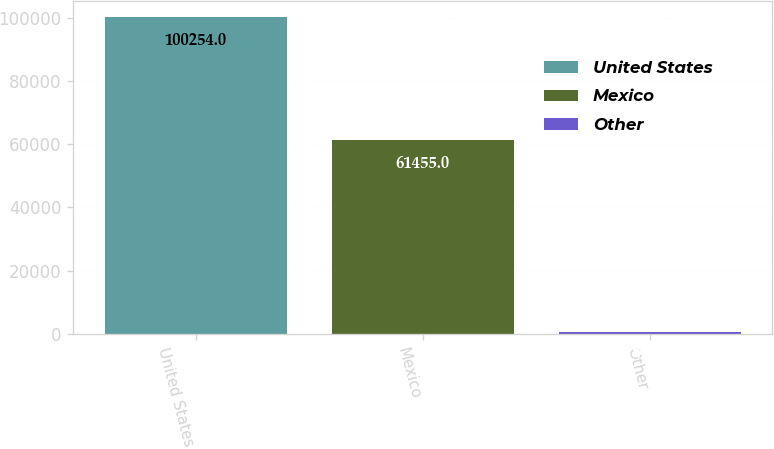<chart> <loc_0><loc_0><loc_500><loc_500><bar_chart><fcel>United States<fcel>Mexico<fcel>Other<nl><fcel>100254<fcel>61455<fcel>590<nl></chart> 